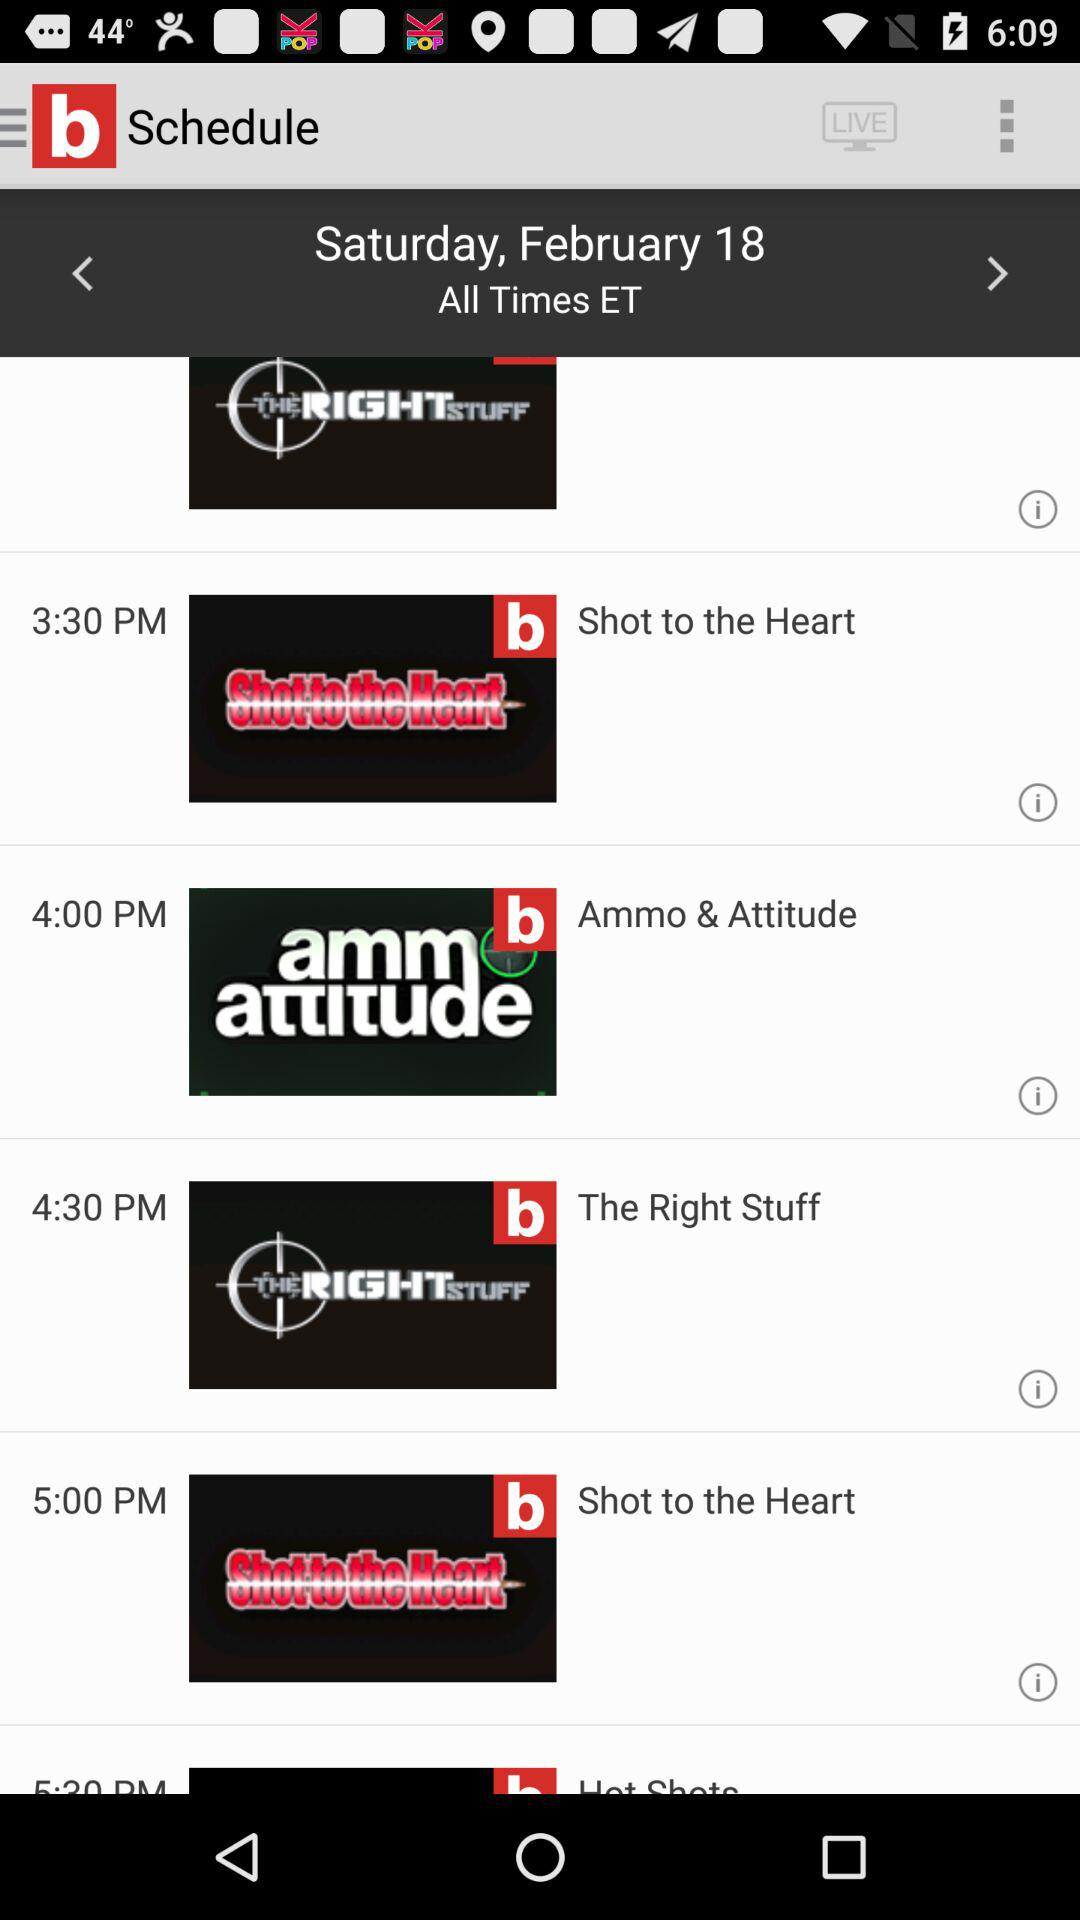What is the time for "Shot to the Heart"? The times for "Shot to the Heart" are 5 p.m. and 3:30 p.m. 